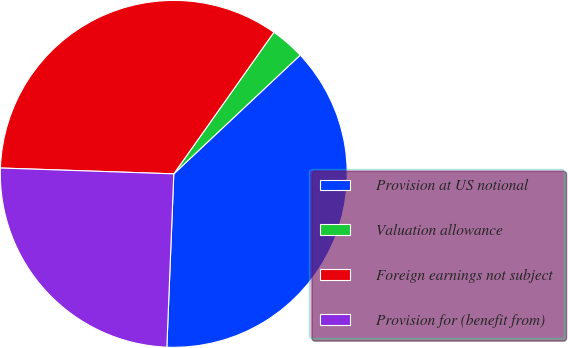Convert chart to OTSL. <chart><loc_0><loc_0><loc_500><loc_500><pie_chart><fcel>Provision at US notional<fcel>Valuation allowance<fcel>Foreign earnings not subject<fcel>Provision for (benefit from)<nl><fcel>37.64%<fcel>3.2%<fcel>34.26%<fcel>24.9%<nl></chart> 